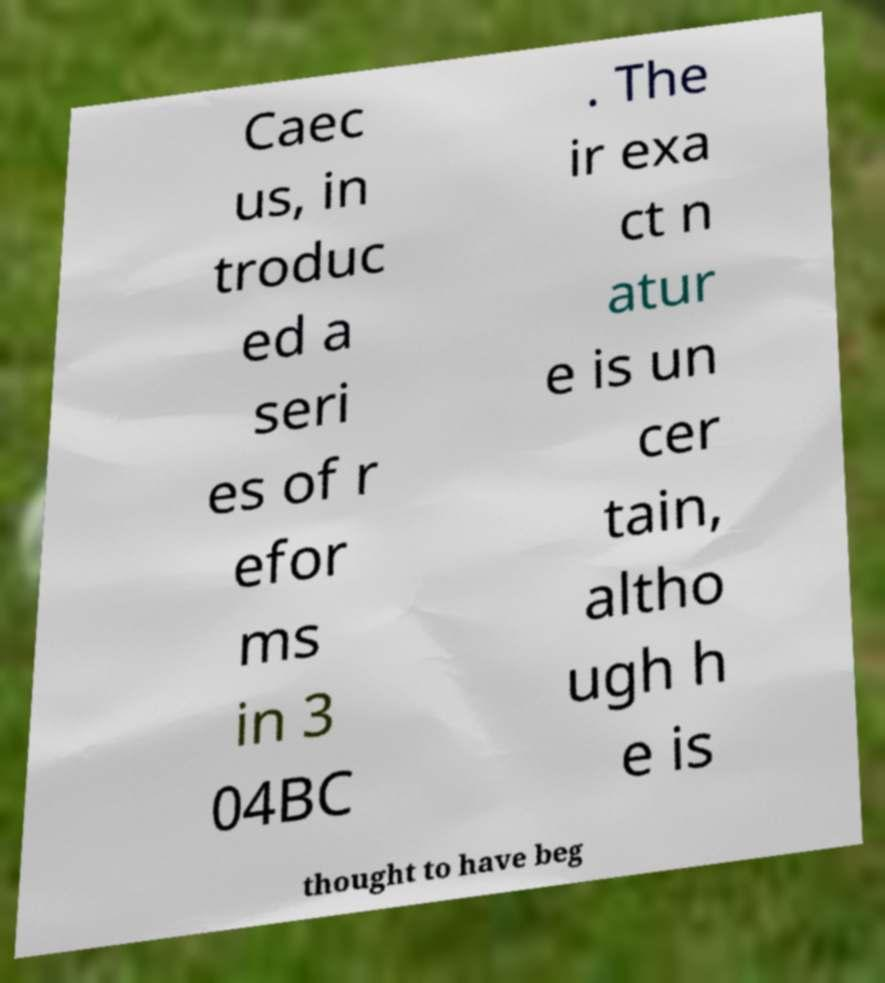Please read and relay the text visible in this image. What does it say? Caec us, in troduc ed a seri es of r efor ms in 3 04BC . The ir exa ct n atur e is un cer tain, altho ugh h e is thought to have beg 